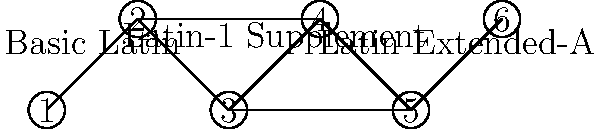En el grafo que representa las relaciones entre bloques Unicode, ¿cuántos puentes (bridges) existen? Considera que cada arista representa una relación entre bloques adyacentes y que los nodos representan bloques Unicode específicos. Para identificar los puentes en este grafo, seguiremos estos pasos:

1. Recordemos que un puente es una arista cuya eliminación incrementaría el número de componentes conectados en el grafo.

2. Analizamos cada arista:
   a) Arista (1-2): Si se elimina, el grafo sigue conectado. No es un puente.
   b) Arista (2-3): Si se elimina, el grafo se divide en dos componentes. Es un puente.
   c) Arista (3-4): Si se elimina, el grafo sigue conectado. No es un puente.
   d) Arista (4-5): Si se elimina, el grafo se divide en dos componentes. Es un puente.
   e) Arista (5-6): Si se elimina, el grafo se divide en dos componentes. Es un puente.
   f) Arista (2-4): Si se elimina, el grafo sigue conectado. No es un puente.

3. Contamos el número de puentes identificados: 3 (aristas 2-3, 4-5, y 5-6).

Esta estructura refleja cómo los bloques Unicode están interconectados, donde los puentes representan relaciones críticas entre bloques adyacentes que, si se rompen, podrían causar problemas de compatibilidad o codificación entre diferentes rangos de caracteres.
Answer: 3 